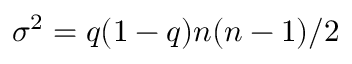Convert formula to latex. <formula><loc_0><loc_0><loc_500><loc_500>\sigma ^ { 2 } = q ( 1 - q ) n ( n - 1 ) / 2</formula> 